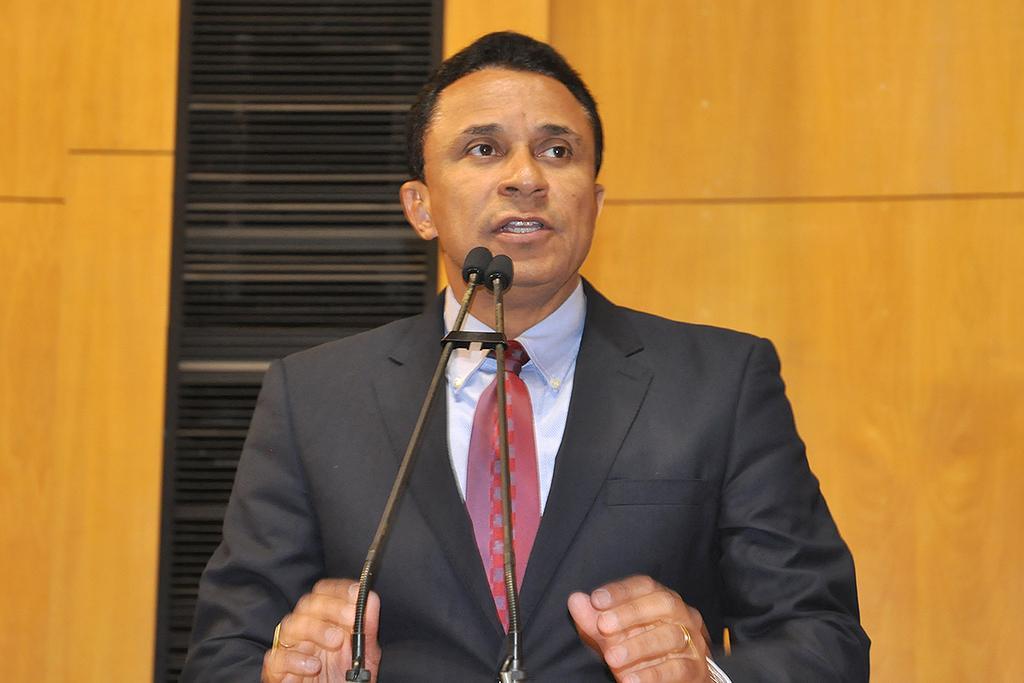How would you summarize this image in a sentence or two? The man in the middle of the picture wearing the blue shirt and black blazer is talking on the microphone, which is placed in front of him. Behind him, we see a wall in yellow color and we even see a wall in black color. This picture might be clicked in a conference hall. 